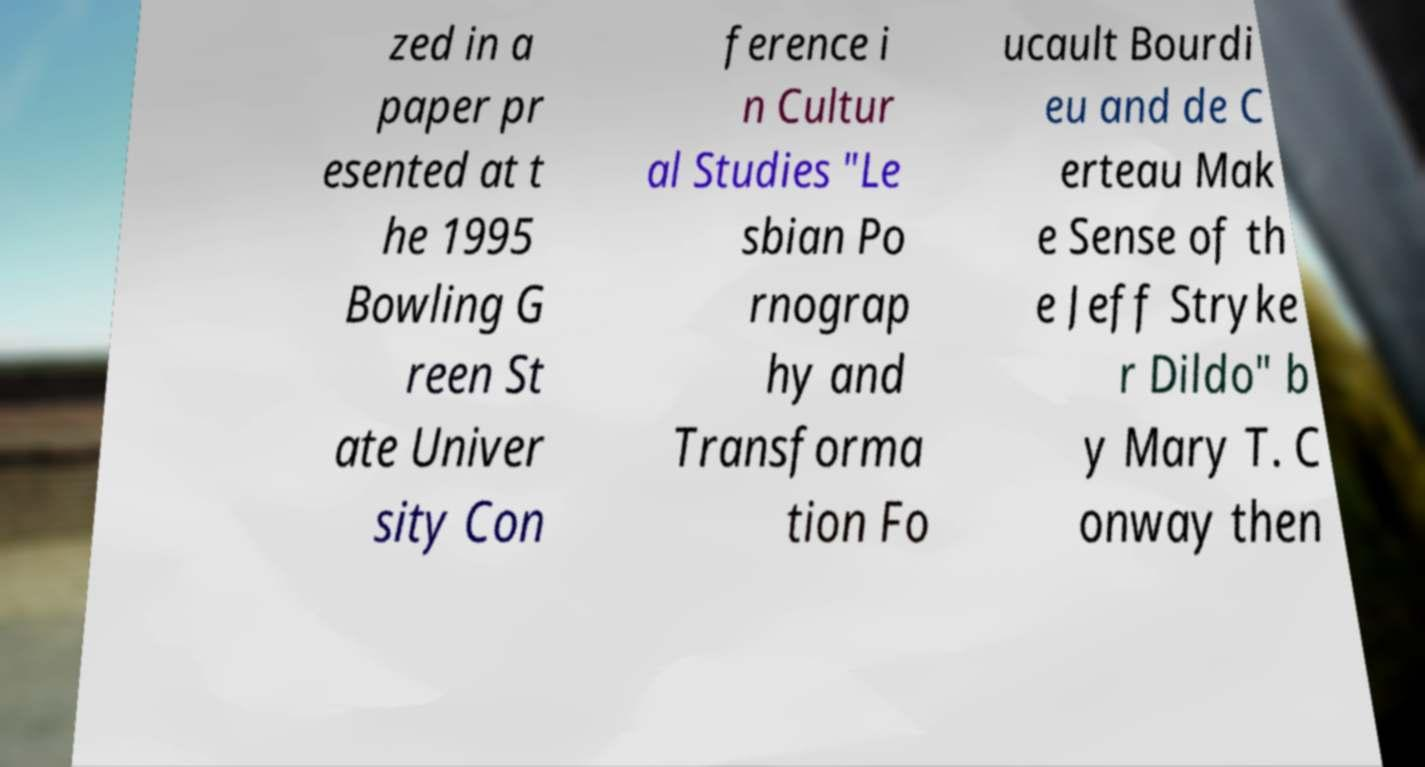Can you accurately transcribe the text from the provided image for me? zed in a paper pr esented at t he 1995 Bowling G reen St ate Univer sity Con ference i n Cultur al Studies "Le sbian Po rnograp hy and Transforma tion Fo ucault Bourdi eu and de C erteau Mak e Sense of th e Jeff Stryke r Dildo" b y Mary T. C onway then 